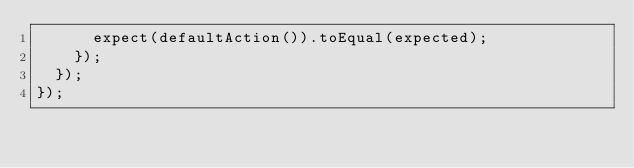Convert code to text. <code><loc_0><loc_0><loc_500><loc_500><_JavaScript_>      expect(defaultAction()).toEqual(expected);
    });
  });
});
</code> 